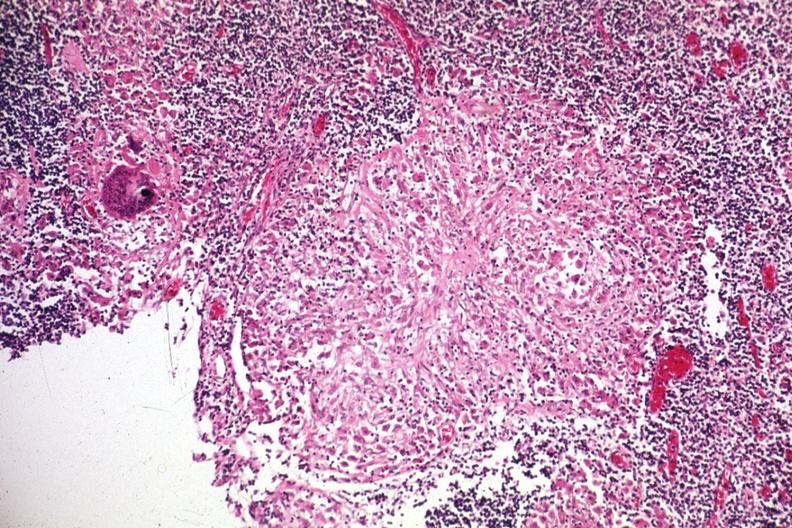s sarcoidosis present?
Answer the question using a single word or phrase. Yes 